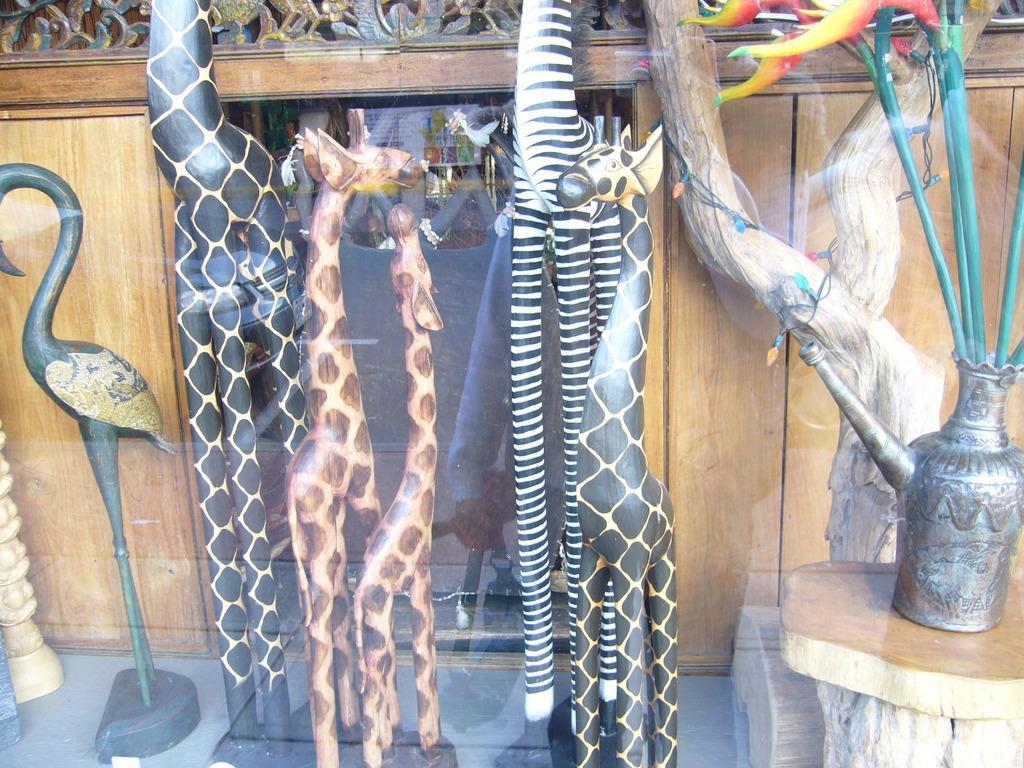Could you give a brief overview of what you see in this image? In this image there are crafts, in the background there is a wooden wall. 